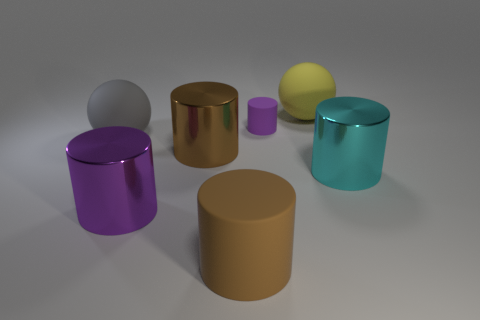Is there a large object that has the same color as the big matte cylinder?
Your answer should be compact. Yes. Are any matte spheres visible?
Provide a succinct answer. Yes. Is there a matte cylinder that is in front of the metal object on the right side of the matte cylinder in front of the big purple metal cylinder?
Give a very brief answer. Yes. What number of big things are either blue cubes or yellow balls?
Keep it short and to the point. 1. What is the color of the matte cylinder that is the same size as the purple metal cylinder?
Your answer should be very brief. Brown. There is a purple matte cylinder; what number of cylinders are right of it?
Your answer should be compact. 1. Is there a big thing that has the same material as the tiny purple object?
Your answer should be very brief. Yes. The big thing that is the same color as the small matte cylinder is what shape?
Your response must be concise. Cylinder. The rubber object in front of the brown metallic cylinder is what color?
Provide a short and direct response. Brown. Are there the same number of big cylinders to the left of the large brown metal thing and brown cylinders that are right of the large cyan cylinder?
Offer a very short reply. No. 